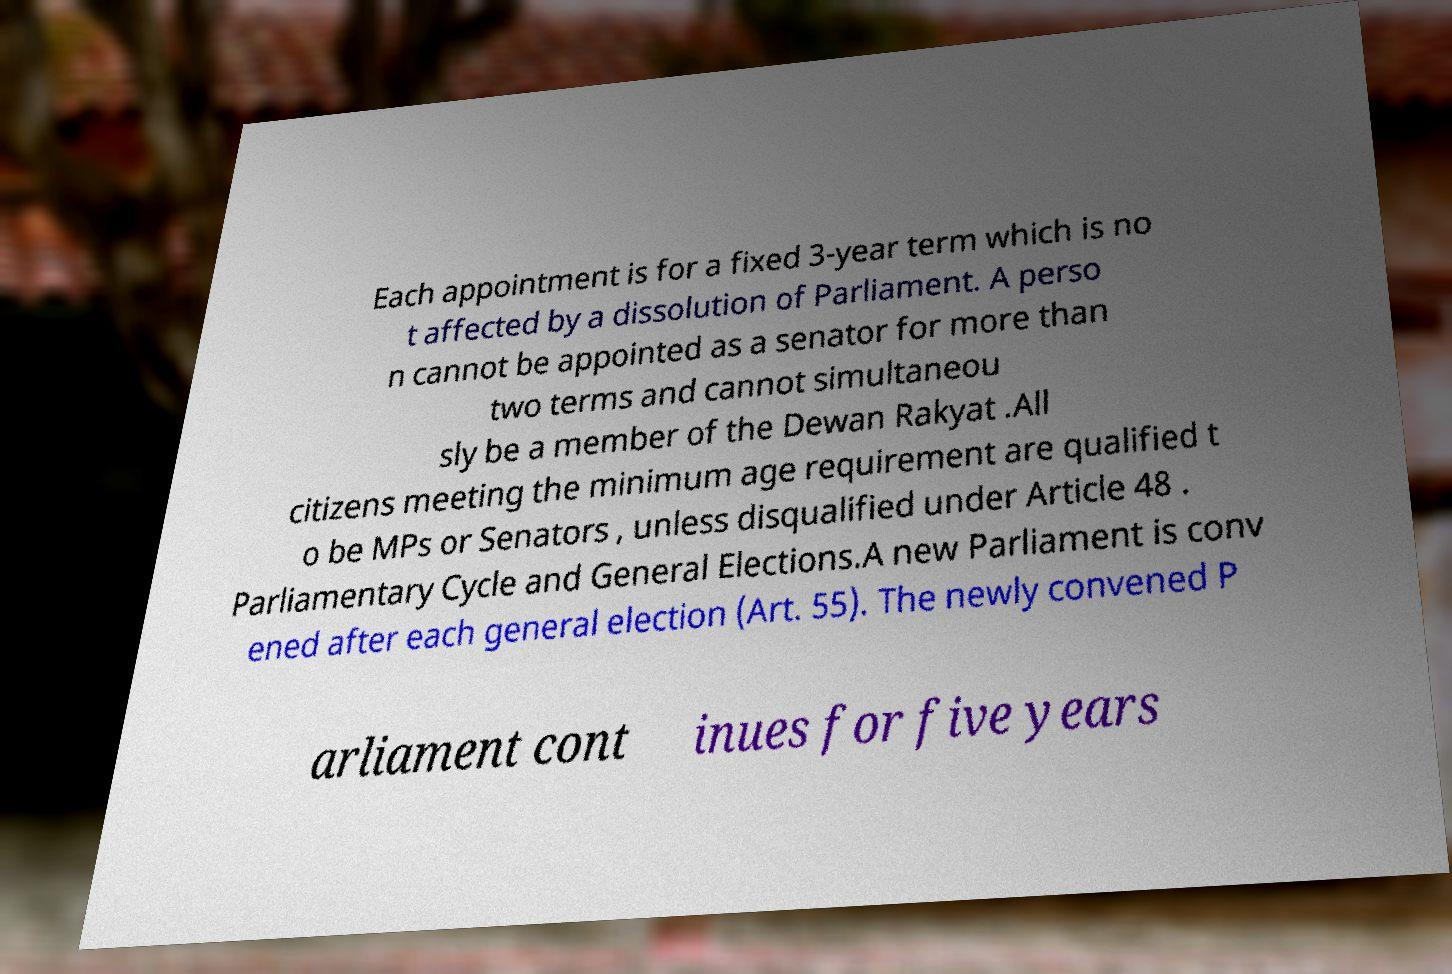Can you read and provide the text displayed in the image?This photo seems to have some interesting text. Can you extract and type it out for me? Each appointment is for a fixed 3-year term which is no t affected by a dissolution of Parliament. A perso n cannot be appointed as a senator for more than two terms and cannot simultaneou sly be a member of the Dewan Rakyat .All citizens meeting the minimum age requirement are qualified t o be MPs or Senators , unless disqualified under Article 48 . Parliamentary Cycle and General Elections.A new Parliament is conv ened after each general election (Art. 55). The newly convened P arliament cont inues for five years 